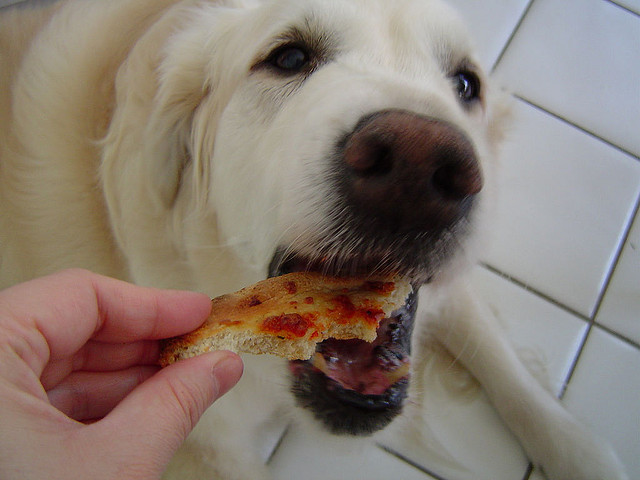<image>What color is the nail polish on the woman's finger? There is no clear indication of the color of nail polish on the woman's finger. What color is the nail polish on the woman's finger? It is not possible to determine the color of the nail polish on the woman's finger. There is no polish seen. 